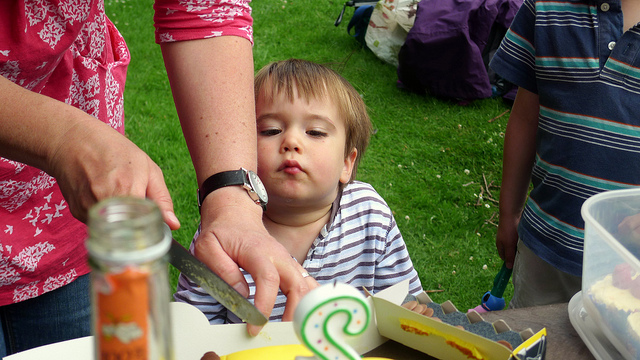What food items can be seen on the table? On the table, there are a few visible food items, including what appears to be a bottle of seasoning or condiments, some snacks possibly in open containers, and a decorative spiral item that might be related to festivities or simply part of the table setting. 